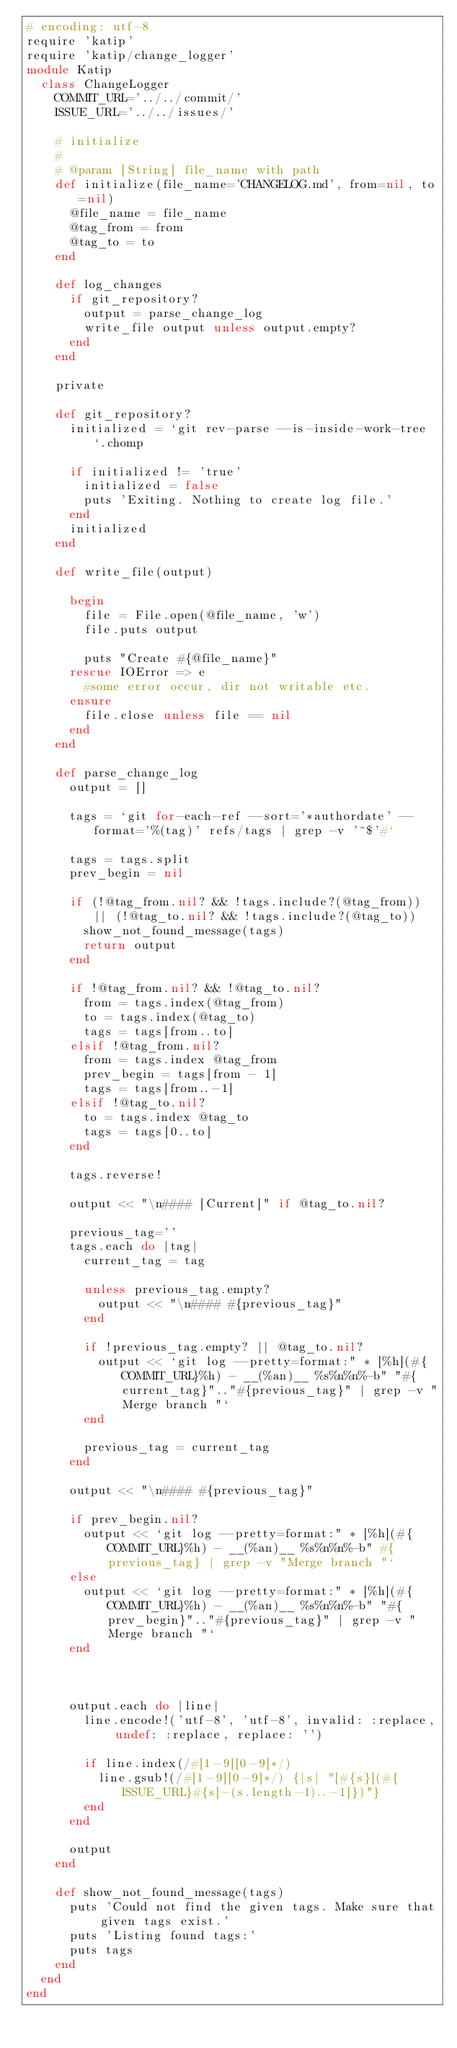<code> <loc_0><loc_0><loc_500><loc_500><_Ruby_># encoding: utf-8
require 'katip'
require 'katip/change_logger'
module Katip
  class ChangeLogger
    COMMIT_URL='../../commit/'
    ISSUE_URL='../../issues/'

    # initialize
    #
    # @param [String] file_name with path
    def initialize(file_name='CHANGELOG.md', from=nil, to=nil)
      @file_name = file_name
      @tag_from = from
      @tag_to = to
    end

    def log_changes
      if git_repository?
        output = parse_change_log
        write_file output unless output.empty?
      end
    end

    private

    def git_repository?
      initialized = `git rev-parse --is-inside-work-tree`.chomp

      if initialized != 'true'
        initialized = false
        puts 'Exiting. Nothing to create log file.'
      end
      initialized
    end

    def write_file(output)

      begin
        file = File.open(@file_name, 'w')
        file.puts output

        puts "Create #{@file_name}"
      rescue IOError => e
        #some error occur, dir not writable etc.
      ensure
        file.close unless file == nil
      end
    end

    def parse_change_log
      output = []

      tags = `git for-each-ref --sort='*authordate' --format='%(tag)' refs/tags | grep -v '^$'#`

      tags = tags.split
      prev_begin = nil

      if (!@tag_from.nil? && !tags.include?(@tag_from)) || (!@tag_to.nil? && !tags.include?(@tag_to))
        show_not_found_message(tags)
        return output
      end

      if !@tag_from.nil? && !@tag_to.nil?
        from = tags.index(@tag_from)
        to = tags.index(@tag_to)
        tags = tags[from..to]
      elsif !@tag_from.nil?
        from = tags.index @tag_from
        prev_begin = tags[from - 1]
        tags = tags[from..-1]
      elsif !@tag_to.nil?
        to = tags.index @tag_to
        tags = tags[0..to]
      end

      tags.reverse!

      output << "\n#### [Current]" if @tag_to.nil?

      previous_tag=''
      tags.each do |tag|
        current_tag = tag

        unless previous_tag.empty?
          output << "\n#### #{previous_tag}"
        end

        if !previous_tag.empty? || @tag_to.nil?
          output << `git log --pretty=format:" * [%h](#{COMMIT_URL}%h) - __(%an)__ %s%n%n%-b" "#{current_tag}".."#{previous_tag}" | grep -v "Merge branch "`
        end

        previous_tag = current_tag
      end

      output << "\n#### #{previous_tag}"

      if prev_begin.nil?
        output << `git log --pretty=format:" * [%h](#{COMMIT_URL}%h) - __(%an)__ %s%n%n%-b" #{previous_tag} | grep -v "Merge branch "`
      else
        output << `git log --pretty=format:" * [%h](#{COMMIT_URL}%h) - __(%an)__ %s%n%n%-b" "#{prev_begin}".."#{previous_tag}" | grep -v "Merge branch "`
      end



      output.each do |line|
        line.encode!('utf-8', 'utf-8', invalid: :replace, undef: :replace, replace: '')

        if line.index(/#[1-9][0-9]*/)
          line.gsub!(/#[1-9][0-9]*/) {|s| "[#{s}](#{ISSUE_URL}#{s[-(s.length-1)..-1]})"}
        end
      end

      output
    end

    def show_not_found_message(tags)
      puts 'Could not find the given tags. Make sure that given tags exist.'
      puts 'Listing found tags:'
      puts tags
    end
  end
end
</code> 